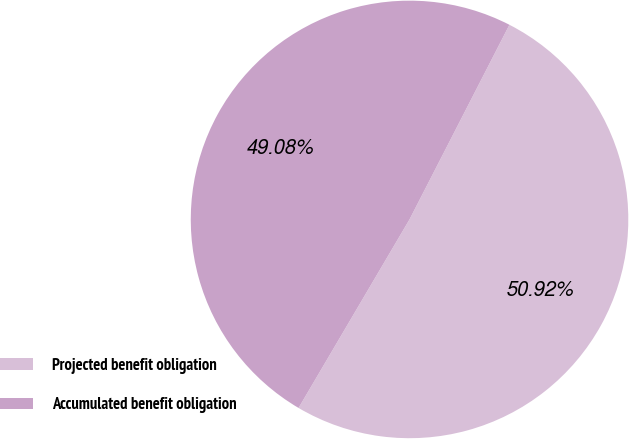Convert chart to OTSL. <chart><loc_0><loc_0><loc_500><loc_500><pie_chart><fcel>Projected benefit obligation<fcel>Accumulated benefit obligation<nl><fcel>50.92%<fcel>49.08%<nl></chart> 